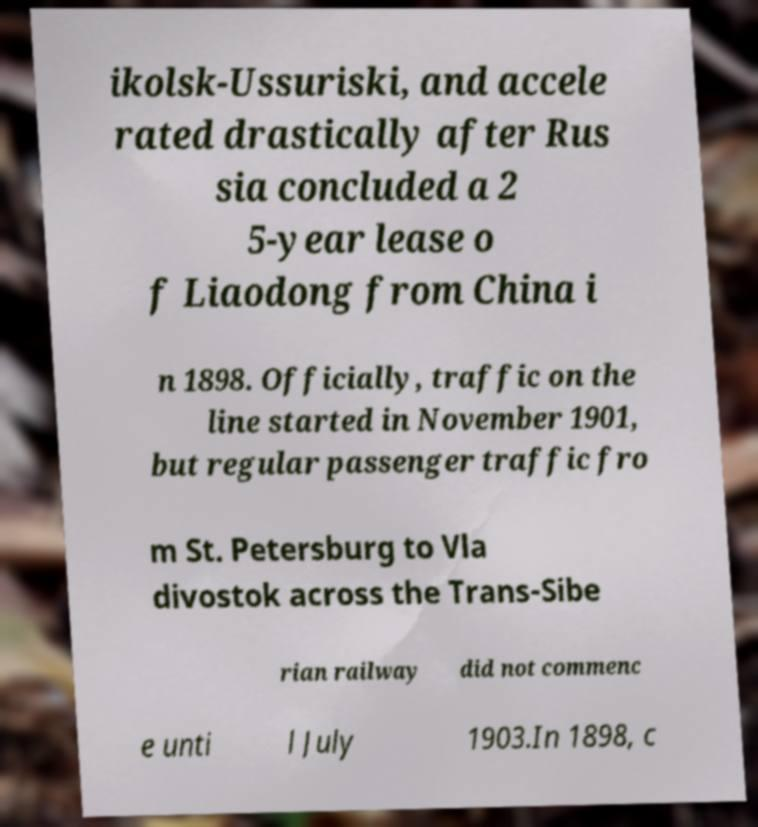Can you read and provide the text displayed in the image?This photo seems to have some interesting text. Can you extract and type it out for me? ikolsk-Ussuriski, and accele rated drastically after Rus sia concluded a 2 5-year lease o f Liaodong from China i n 1898. Officially, traffic on the line started in November 1901, but regular passenger traffic fro m St. Petersburg to Vla divostok across the Trans-Sibe rian railway did not commenc e unti l July 1903.In 1898, c 